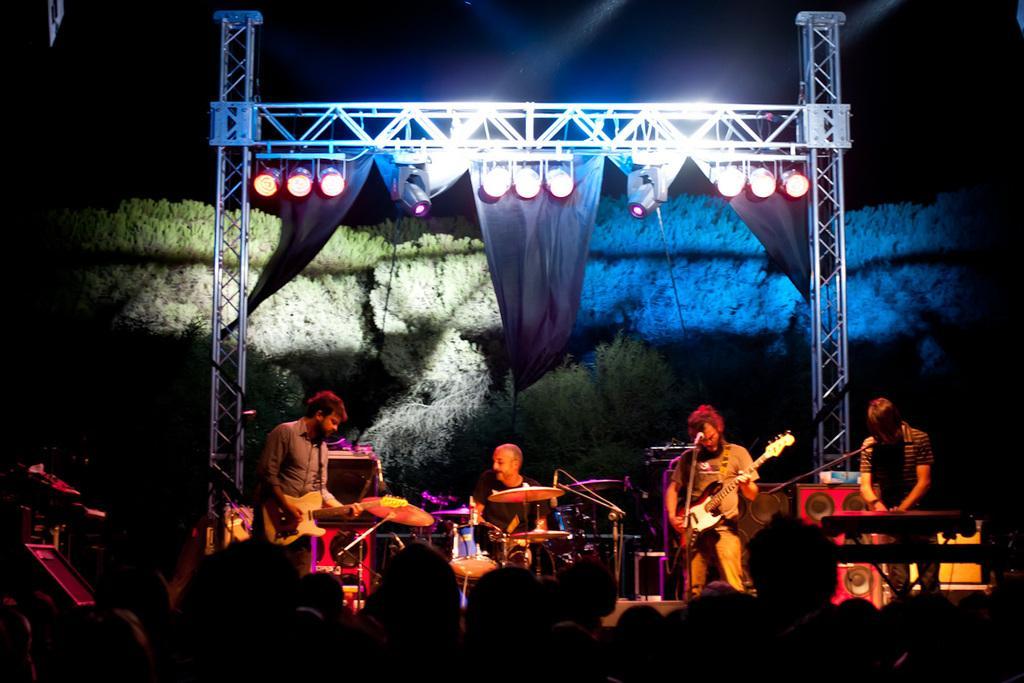Could you give a brief overview of what you see in this image? It is an open place where four people are performing on the stage, behind them there are trees and black curtains and lights on them. In Front of the stage there is crowd, on the right corner of the picture a person is playing keyboard beside him a person is playing guitar, beside him a person is playing drums and in the left corner of the picture a person is playing a guitar and it is very dark in the background. 